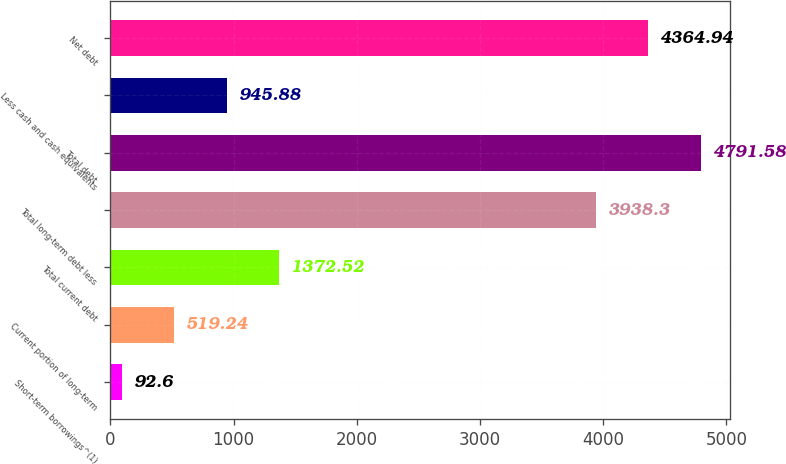Convert chart to OTSL. <chart><loc_0><loc_0><loc_500><loc_500><bar_chart><fcel>Short-term borrowings^(1)<fcel>Current portion of long-term<fcel>Total current debt<fcel>Total long-term debt less<fcel>Total debt<fcel>Less cash and cash equivalents<fcel>Net debt<nl><fcel>92.6<fcel>519.24<fcel>1372.52<fcel>3938.3<fcel>4791.58<fcel>945.88<fcel>4364.94<nl></chart> 